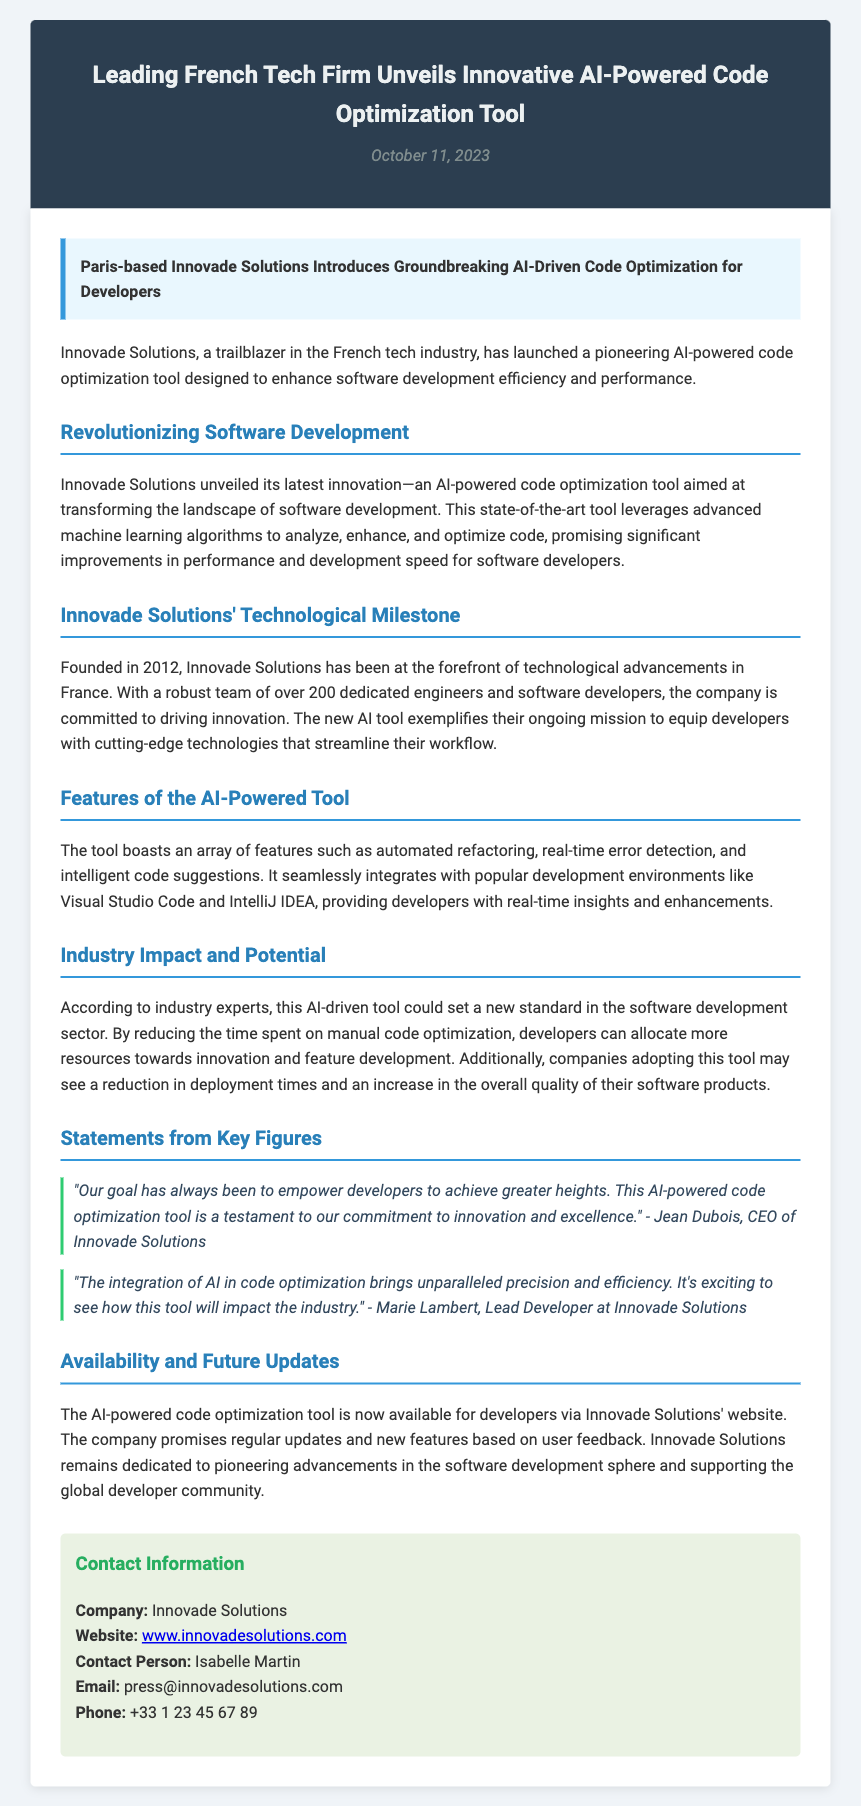What is the name of the firm that launched the tool? The document states that Innovade Solutions is the company that launched the tool.
Answer: Innovade Solutions When was the AI-powered code optimization tool launched? The launch date mentioned in the document is October 11, 2023.
Answer: October 11, 2023 What city is Innovade Solutions based in? The press release specifies that Innovade Solutions is based in Paris.
Answer: Paris Who is the CEO of Innovade Solutions? Jean Dubois is identified as the CEO of Innovade Solutions in the quotes section.
Answer: Jean Dubois What feature does the tool offer that relates to error management? The document mentions real-time error detection as a feature of the tool.
Answer: Real-time error detection How many engineers and software developers work at Innovade Solutions? The document states that there are over 200 dedicated engineers and software developers.
Answer: Over 200 According to industry experts, what will the AI tool reduce? It is mentioned that the AI-driven tool could reduce the time spent on manual code optimization.
Answer: Manual code optimization What type of feedback will contribute to future updates of the tool? The document indicates that user feedback will be used for regular updates and new features.
Answer: User feedback What is the contact email for press inquiries? The document specifies that the contact email for press inquiries is press@innovadesolutions.com.
Answer: press@innovadesolutions.com 